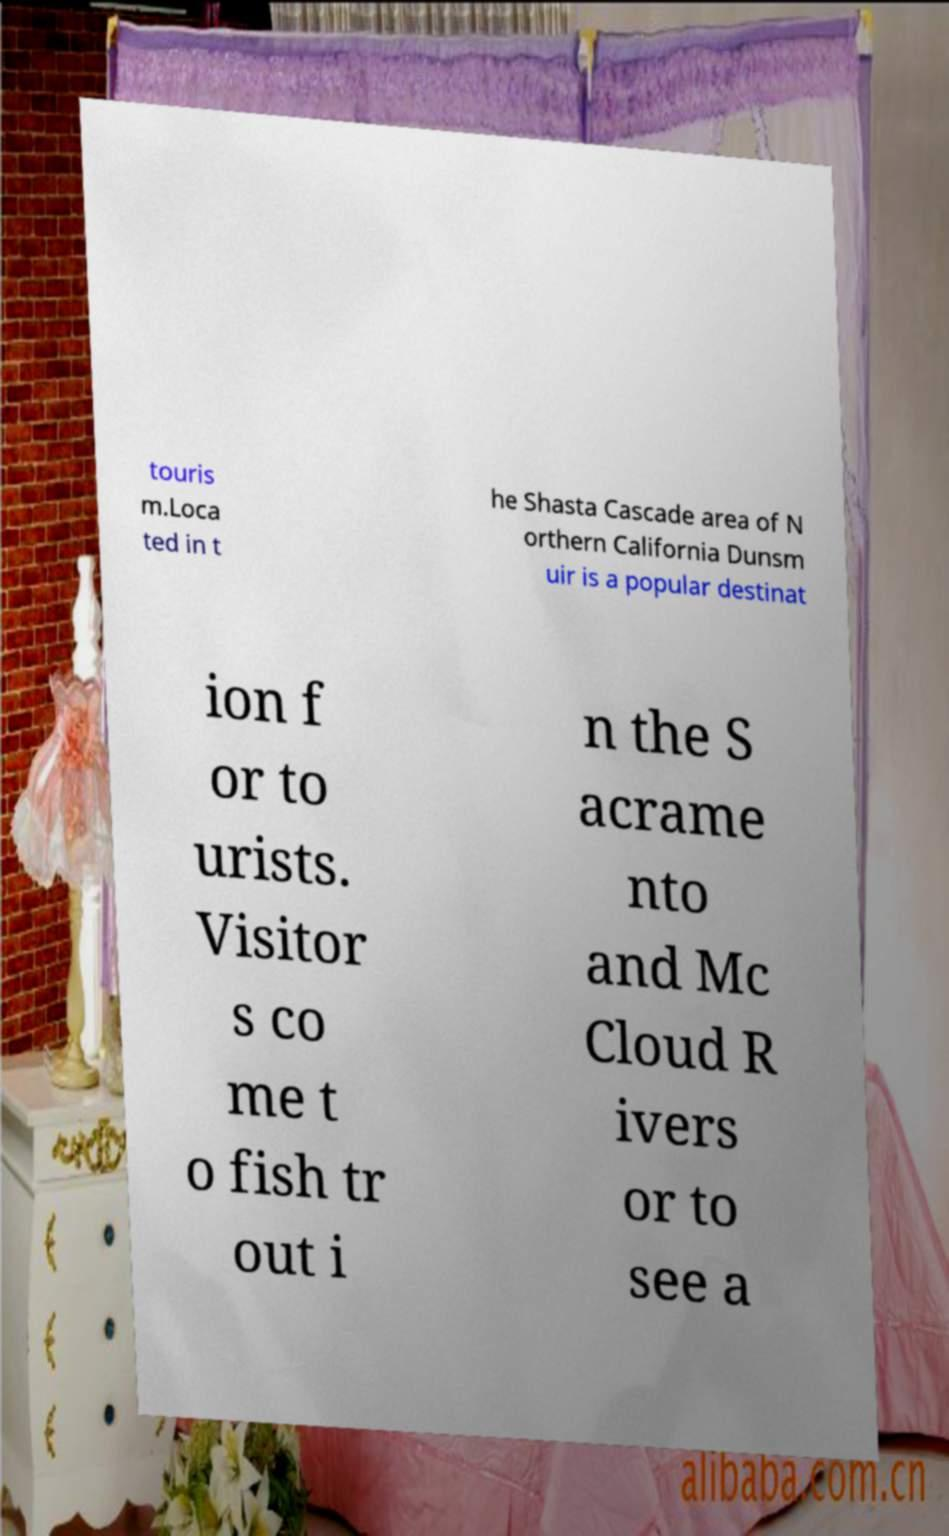I need the written content from this picture converted into text. Can you do that? touris m.Loca ted in t he Shasta Cascade area of N orthern California Dunsm uir is a popular destinat ion f or to urists. Visitor s co me t o fish tr out i n the S acrame nto and Mc Cloud R ivers or to see a 